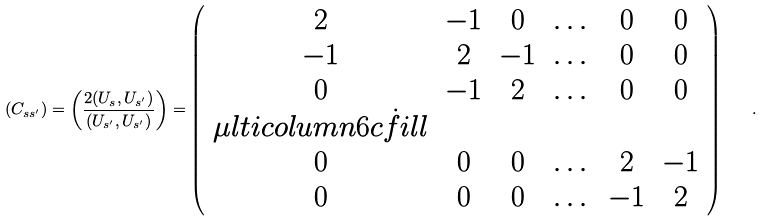<formula> <loc_0><loc_0><loc_500><loc_500>\left ( C _ { s s ^ { \prime } } \right ) = \left ( \frac { 2 ( U _ { s } , U _ { s ^ { \prime } } ) } { ( U _ { s ^ { \prime } } , U _ { s ^ { \prime } } ) } \right ) = \left ( \begin{array} { * { 6 } { c } } 2 & - 1 & 0 & \dots & 0 & 0 \\ - 1 & 2 & - 1 & \dots & 0 & 0 \\ 0 & - 1 & 2 & \dots & 0 & 0 \\ \mu l t i c o l u m n { 6 } { c } { \dot { f } i l l } \\ 0 & 0 & 0 & \dots & 2 & - 1 \\ 0 & 0 & 0 & \dots & - 1 & 2 \end{array} \right ) \quad .</formula> 